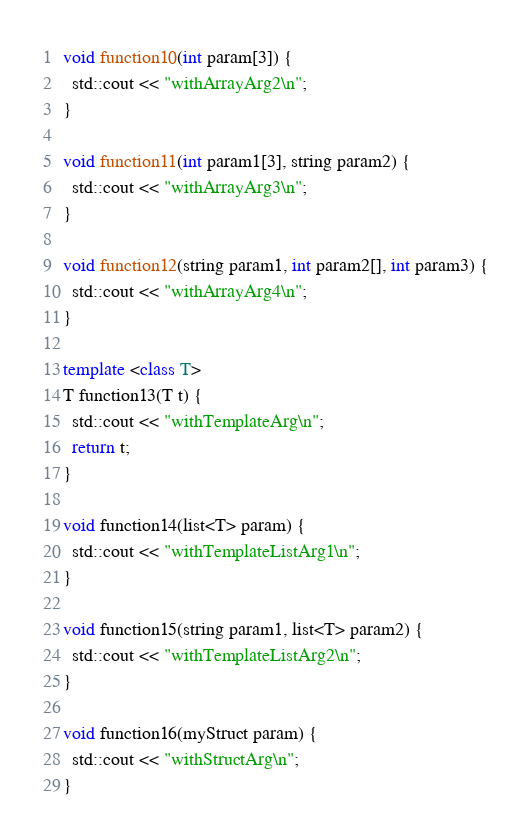Convert code to text. <code><loc_0><loc_0><loc_500><loc_500><_C++_>void function10(int param[3]) {
  std::cout << "withArrayArg2\n";
}

void function11(int param1[3], string param2) {
  std::cout << "withArrayArg3\n";
}

void function12(string param1, int param2[], int param3) {
  std::cout << "withArrayArg4\n";
}

template <class T>
T function13(T t) {
  std::cout << "withTemplateArg\n";
  return t;
}

void function14(list<T> param) {
  std::cout << "withTemplateListArg1\n";
}

void function15(string param1, list<T> param2) {
  std::cout << "withTemplateListArg2\n";
}

void function16(myStruct param) {
  std::cout << "withStructArg\n";
}</code> 